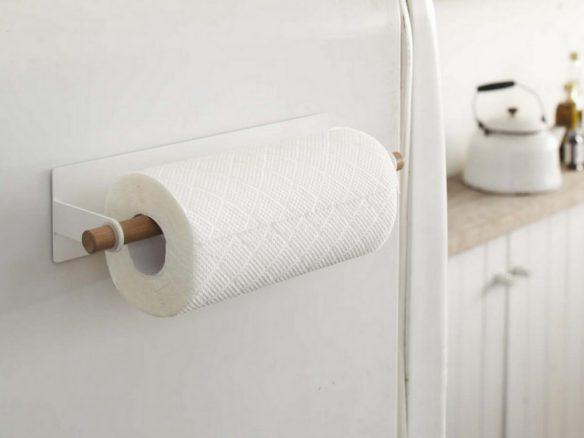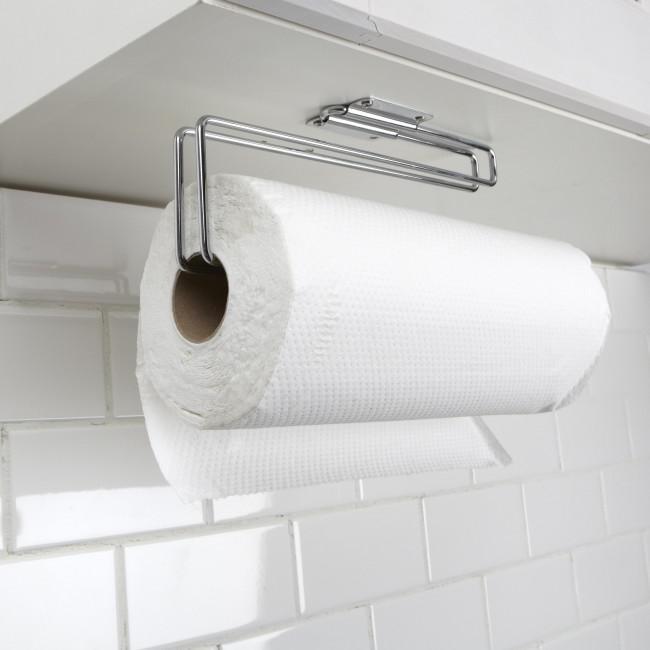The first image is the image on the left, the second image is the image on the right. Examine the images to the left and right. Is the description "The paper towels on the left are hanging under a cabinet." accurate? Answer yes or no. No. The first image is the image on the left, the second image is the image on the right. For the images shown, is this caption "An image shows a roll of towels suspended on a chrome wire bar mounted on the underside of a surface." true? Answer yes or no. Yes. 